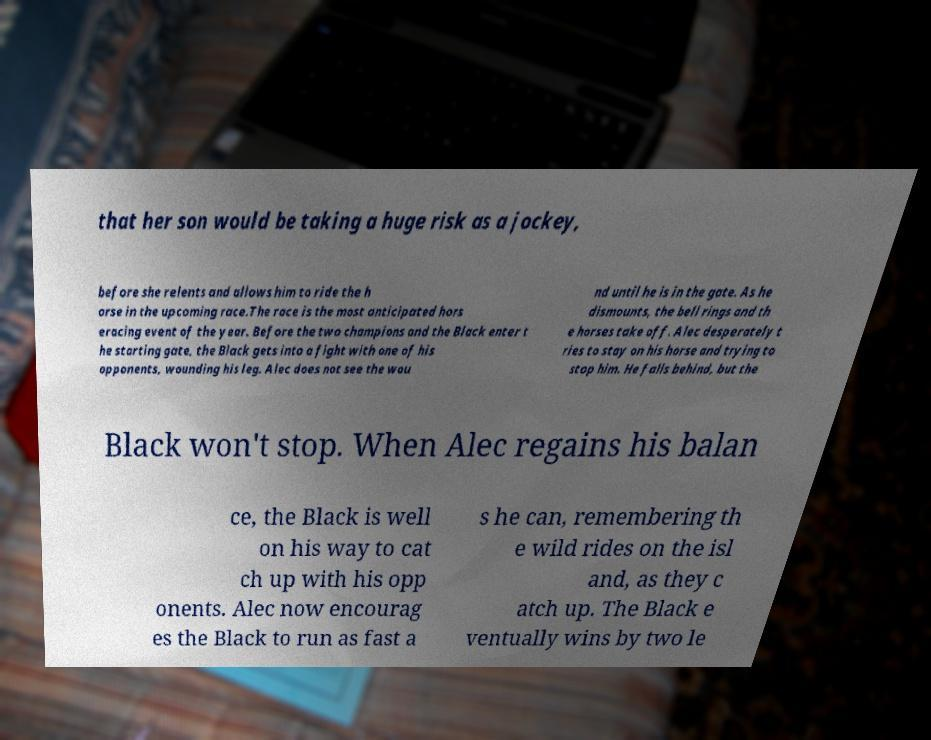Could you extract and type out the text from this image? that her son would be taking a huge risk as a jockey, before she relents and allows him to ride the h orse in the upcoming race.The race is the most anticipated hors eracing event of the year. Before the two champions and the Black enter t he starting gate, the Black gets into a fight with one of his opponents, wounding his leg. Alec does not see the wou nd until he is in the gate. As he dismounts, the bell rings and th e horses take off. Alec desperately t ries to stay on his horse and trying to stop him. He falls behind, but the Black won't stop. When Alec regains his balan ce, the Black is well on his way to cat ch up with his opp onents. Alec now encourag es the Black to run as fast a s he can, remembering th e wild rides on the isl and, as they c atch up. The Black e ventually wins by two le 